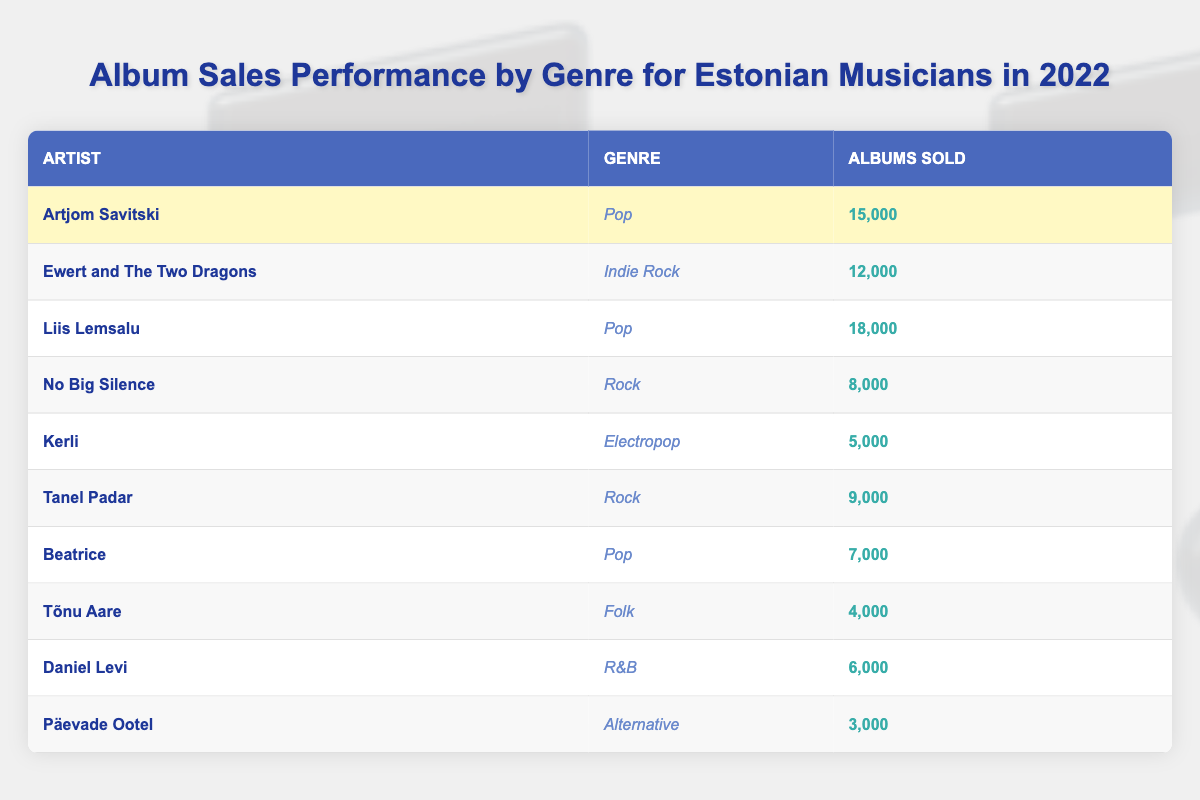What was the total number of albums sold by Artjom Savitski? The table shows that Artjom Savitski sold 15,000 albums in 2022.
Answer: 15,000 Which genre had the highest album sales in 2022? By comparing the albums sold, Pop is the genre with the highest sales at 18,000 by Liis Lemsalu.
Answer: Pop How many albums did Ewert and The Two Dragons sell? The table indicates that Ewert and The Two Dragons sold 12,000 albums in 2022.
Answer: 12,000 What is the total number of albums sold by Rock genre artists? Tanel Padar sold 9,000 and No Big Silence sold 8,000, thus total Rock sales = 9,000 + 8,000 = 17,000.
Answer: 17,000 Did Kerli sell more than 10,000 albums? According to the table, Kerli sold 5,000 albums, which is less than 10,000.
Answer: No What is the average number of albums sold by Pop artists? The Pop artists are Artjom Savitski (15,000), Liis Lemsalu (18,000), and Beatrice (7,000). The sum is 15,000 + 18,000 + 7,000 = 40,000. There are 3 artists, so the average is 40,000 / 3 ≈ 13,333.
Answer: 13,333 Which artist sold the least number of albums? By examining the table, Päevade Ootel sold the least with 3,000 albums.
Answer: Päevade Ootel What is the difference in albums sold between the highest and lowest selling artist? The highest selling artist is Liis Lemsalu with 18,000 albums and the lowest is Päevade Ootel with 3,000 albums. The difference is 18,000 - 3,000 = 15,000.
Answer: 15,000 Which genres had sales over 7,000 albums? From the table, the genres with over 7,000 albums sold are Pop (Artjom Savitski, Liis Lemsalu, Beatrice) and Indie Rock (Ewert and The Two Dragons).
Answer: Pop, Indie Rock How many artists sold more than 10,000 albums? The artists with sales over 10,000 are Liis Lemsalu (18,000), Artjom Savitski (15,000), and Ewert and The Two Dragons (12,000). That’s 3 artists.
Answer: 3 